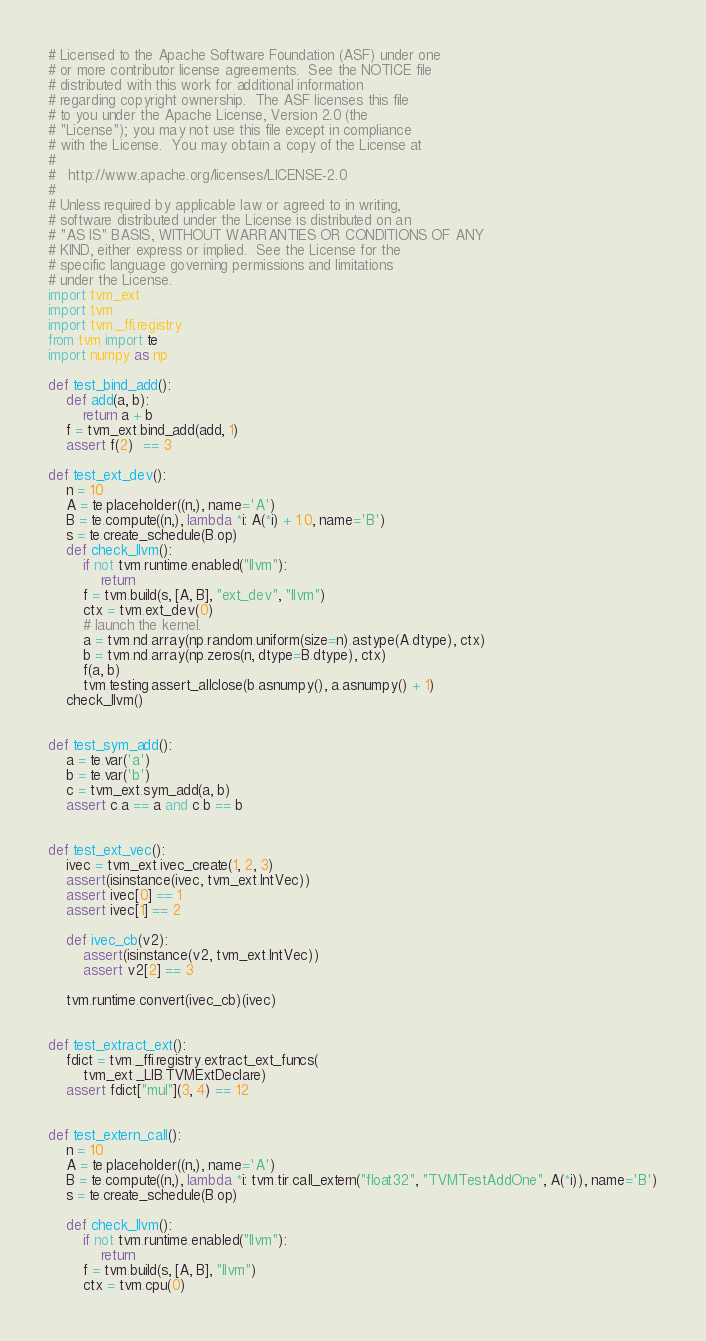Convert code to text. <code><loc_0><loc_0><loc_500><loc_500><_Python_># Licensed to the Apache Software Foundation (ASF) under one
# or more contributor license agreements.  See the NOTICE file
# distributed with this work for additional information
# regarding copyright ownership.  The ASF licenses this file
# to you under the Apache License, Version 2.0 (the
# "License"); you may not use this file except in compliance
# with the License.  You may obtain a copy of the License at
#
#   http://www.apache.org/licenses/LICENSE-2.0
#
# Unless required by applicable law or agreed to in writing,
# software distributed under the License is distributed on an
# "AS IS" BASIS, WITHOUT WARRANTIES OR CONDITIONS OF ANY
# KIND, either express or implied.  See the License for the
# specific language governing permissions and limitations
# under the License.
import tvm_ext
import tvm
import tvm._ffi.registry
from tvm import te
import numpy as np

def test_bind_add():
    def add(a, b):
        return a + b
    f = tvm_ext.bind_add(add, 1)
    assert f(2)  == 3

def test_ext_dev():
    n = 10
    A = te.placeholder((n,), name='A')
    B = te.compute((n,), lambda *i: A(*i) + 1.0, name='B')
    s = te.create_schedule(B.op)
    def check_llvm():
        if not tvm.runtime.enabled("llvm"):
            return
        f = tvm.build(s, [A, B], "ext_dev", "llvm")
        ctx = tvm.ext_dev(0)
        # launch the kernel.
        a = tvm.nd.array(np.random.uniform(size=n).astype(A.dtype), ctx)
        b = tvm.nd.array(np.zeros(n, dtype=B.dtype), ctx)
        f(a, b)
        tvm.testing.assert_allclose(b.asnumpy(), a.asnumpy() + 1)
    check_llvm()


def test_sym_add():
    a = te.var('a')
    b = te.var('b')
    c = tvm_ext.sym_add(a, b)
    assert c.a == a and c.b == b


def test_ext_vec():
    ivec = tvm_ext.ivec_create(1, 2, 3)
    assert(isinstance(ivec, tvm_ext.IntVec))
    assert ivec[0] == 1
    assert ivec[1] == 2

    def ivec_cb(v2):
        assert(isinstance(v2, tvm_ext.IntVec))
        assert v2[2] == 3

    tvm.runtime.convert(ivec_cb)(ivec)


def test_extract_ext():
    fdict = tvm._ffi.registry.extract_ext_funcs(
        tvm_ext._LIB.TVMExtDeclare)
    assert fdict["mul"](3, 4) == 12


def test_extern_call():
    n = 10
    A = te.placeholder((n,), name='A')
    B = te.compute((n,), lambda *i: tvm.tir.call_extern("float32", "TVMTestAddOne", A(*i)), name='B')
    s = te.create_schedule(B.op)

    def check_llvm():
        if not tvm.runtime.enabled("llvm"):
            return
        f = tvm.build(s, [A, B], "llvm")
        ctx = tvm.cpu(0)</code> 